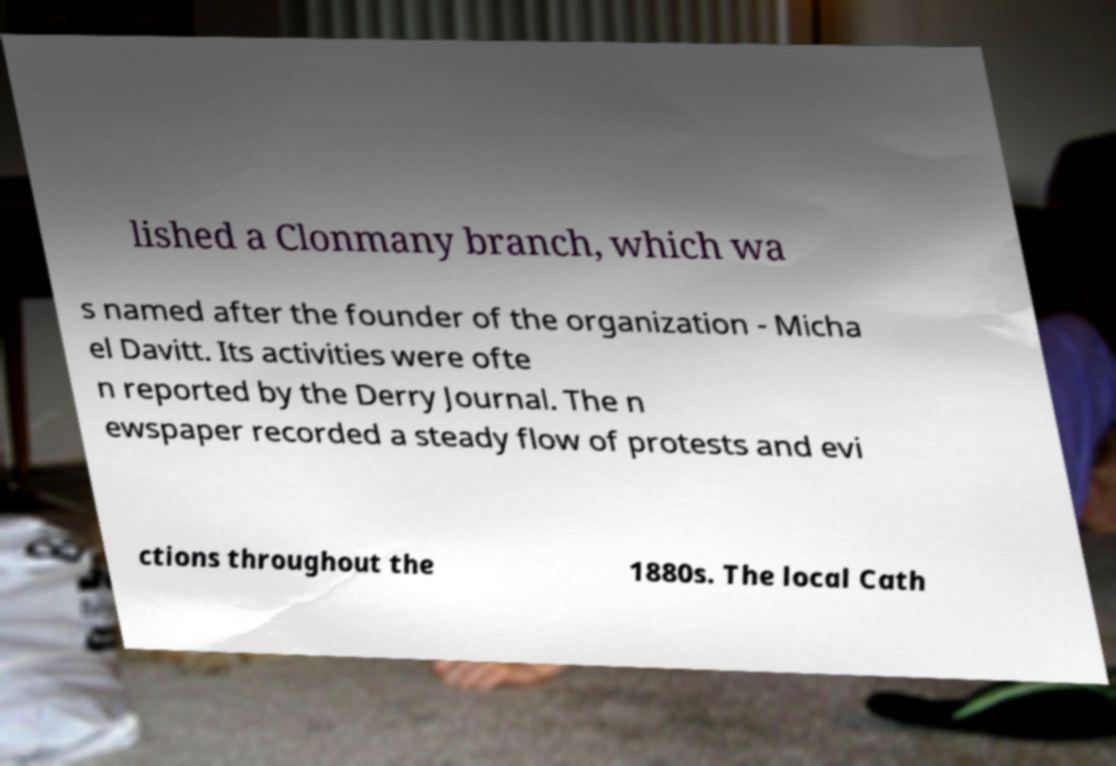Could you extract and type out the text from this image? lished a Clonmany branch, which wa s named after the founder of the organization - Micha el Davitt. Its activities were ofte n reported by the Derry Journal. The n ewspaper recorded a steady flow of protests and evi ctions throughout the 1880s. The local Cath 